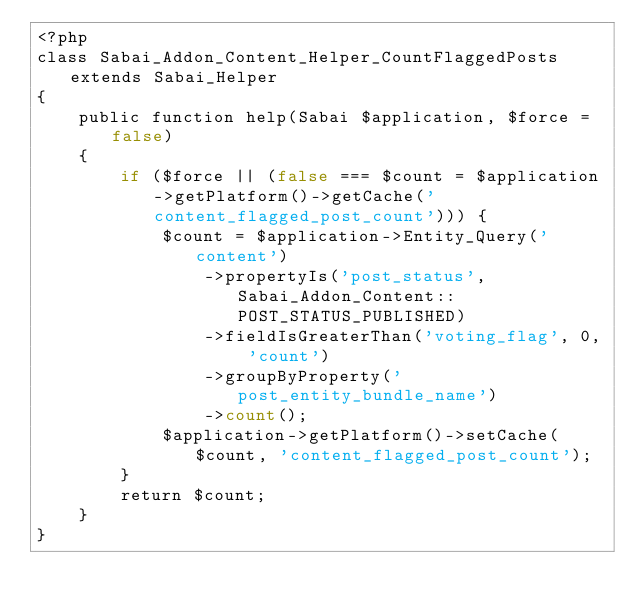Convert code to text. <code><loc_0><loc_0><loc_500><loc_500><_PHP_><?php
class Sabai_Addon_Content_Helper_CountFlaggedPosts extends Sabai_Helper
{
    public function help(Sabai $application, $force = false)
    {
        if ($force || (false === $count = $application->getPlatform()->getCache('content_flagged_post_count'))) {
            $count = $application->Entity_Query('content')
                ->propertyIs('post_status', Sabai_Addon_Content::POST_STATUS_PUBLISHED)
                ->fieldIsGreaterThan('voting_flag', 0, 'count')
                ->groupByProperty('post_entity_bundle_name')
                ->count();
            $application->getPlatform()->setCache($count, 'content_flagged_post_count');
        }
        return $count;
    }
}</code> 